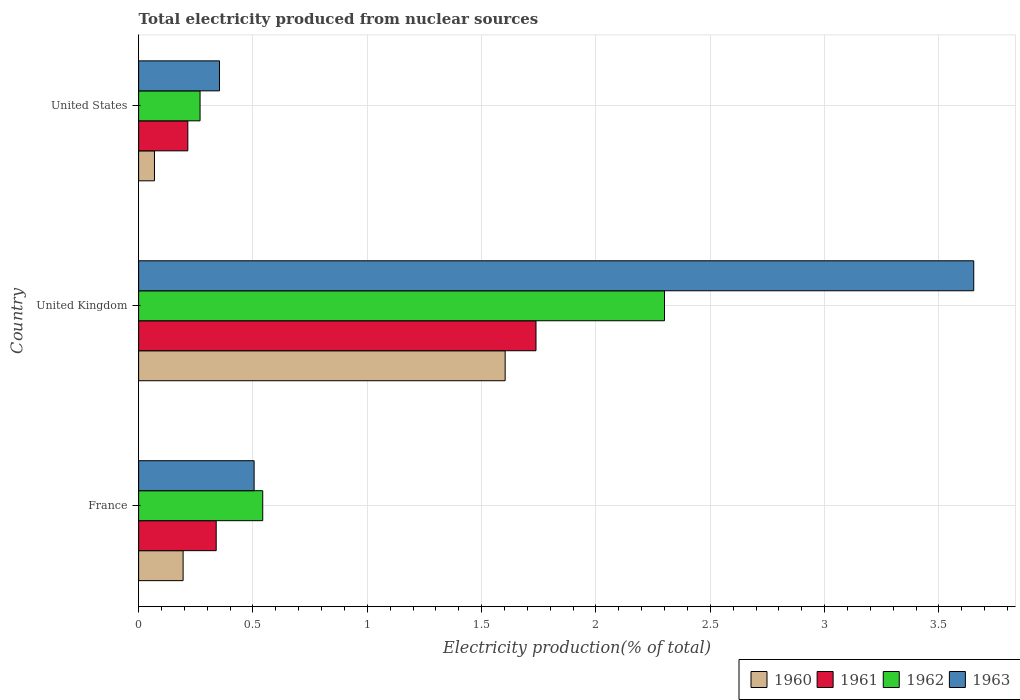How many groups of bars are there?
Offer a terse response. 3. How many bars are there on the 3rd tick from the top?
Make the answer very short. 4. How many bars are there on the 2nd tick from the bottom?
Give a very brief answer. 4. What is the label of the 1st group of bars from the top?
Ensure brevity in your answer.  United States. What is the total electricity produced in 1961 in United Kingdom?
Ensure brevity in your answer.  1.74. Across all countries, what is the maximum total electricity produced in 1961?
Your answer should be very brief. 1.74. Across all countries, what is the minimum total electricity produced in 1963?
Your answer should be very brief. 0.35. In which country was the total electricity produced in 1963 maximum?
Provide a short and direct response. United Kingdom. In which country was the total electricity produced in 1963 minimum?
Keep it short and to the point. United States. What is the total total electricity produced in 1960 in the graph?
Offer a very short reply. 1.87. What is the difference between the total electricity produced in 1961 in France and that in United Kingdom?
Ensure brevity in your answer.  -1.4. What is the difference between the total electricity produced in 1963 in United States and the total electricity produced in 1960 in France?
Ensure brevity in your answer.  0.16. What is the average total electricity produced in 1963 per country?
Your response must be concise. 1.5. What is the difference between the total electricity produced in 1962 and total electricity produced in 1960 in United States?
Ensure brevity in your answer.  0.2. What is the ratio of the total electricity produced in 1961 in France to that in United States?
Offer a very short reply. 1.58. Is the difference between the total electricity produced in 1962 in France and United Kingdom greater than the difference between the total electricity produced in 1960 in France and United Kingdom?
Offer a terse response. No. What is the difference between the highest and the second highest total electricity produced in 1961?
Offer a terse response. 1.4. What is the difference between the highest and the lowest total electricity produced in 1962?
Offer a very short reply. 2.03. What does the 1st bar from the top in United States represents?
Give a very brief answer. 1963. Are all the bars in the graph horizontal?
Your answer should be very brief. Yes. What is the difference between two consecutive major ticks on the X-axis?
Offer a very short reply. 0.5. Are the values on the major ticks of X-axis written in scientific E-notation?
Provide a short and direct response. No. Does the graph contain grids?
Provide a succinct answer. Yes. Where does the legend appear in the graph?
Offer a very short reply. Bottom right. How many legend labels are there?
Offer a very short reply. 4. What is the title of the graph?
Give a very brief answer. Total electricity produced from nuclear sources. Does "1989" appear as one of the legend labels in the graph?
Provide a succinct answer. No. What is the Electricity production(% of total) in 1960 in France?
Give a very brief answer. 0.19. What is the Electricity production(% of total) in 1961 in France?
Offer a terse response. 0.34. What is the Electricity production(% of total) in 1962 in France?
Ensure brevity in your answer.  0.54. What is the Electricity production(% of total) in 1963 in France?
Provide a short and direct response. 0.51. What is the Electricity production(% of total) of 1960 in United Kingdom?
Your answer should be compact. 1.6. What is the Electricity production(% of total) in 1961 in United Kingdom?
Your answer should be very brief. 1.74. What is the Electricity production(% of total) in 1962 in United Kingdom?
Offer a very short reply. 2.3. What is the Electricity production(% of total) in 1963 in United Kingdom?
Your answer should be very brief. 3.65. What is the Electricity production(% of total) of 1960 in United States?
Your response must be concise. 0.07. What is the Electricity production(% of total) of 1961 in United States?
Offer a very short reply. 0.22. What is the Electricity production(% of total) in 1962 in United States?
Offer a very short reply. 0.27. What is the Electricity production(% of total) of 1963 in United States?
Make the answer very short. 0.35. Across all countries, what is the maximum Electricity production(% of total) in 1960?
Make the answer very short. 1.6. Across all countries, what is the maximum Electricity production(% of total) in 1961?
Make the answer very short. 1.74. Across all countries, what is the maximum Electricity production(% of total) in 1962?
Give a very brief answer. 2.3. Across all countries, what is the maximum Electricity production(% of total) in 1963?
Provide a short and direct response. 3.65. Across all countries, what is the minimum Electricity production(% of total) of 1960?
Offer a terse response. 0.07. Across all countries, what is the minimum Electricity production(% of total) of 1961?
Keep it short and to the point. 0.22. Across all countries, what is the minimum Electricity production(% of total) of 1962?
Ensure brevity in your answer.  0.27. Across all countries, what is the minimum Electricity production(% of total) of 1963?
Make the answer very short. 0.35. What is the total Electricity production(% of total) in 1960 in the graph?
Make the answer very short. 1.87. What is the total Electricity production(% of total) in 1961 in the graph?
Your response must be concise. 2.29. What is the total Electricity production(% of total) in 1962 in the graph?
Give a very brief answer. 3.11. What is the total Electricity production(% of total) of 1963 in the graph?
Ensure brevity in your answer.  4.51. What is the difference between the Electricity production(% of total) in 1960 in France and that in United Kingdom?
Your answer should be very brief. -1.41. What is the difference between the Electricity production(% of total) of 1961 in France and that in United Kingdom?
Keep it short and to the point. -1.4. What is the difference between the Electricity production(% of total) in 1962 in France and that in United Kingdom?
Keep it short and to the point. -1.76. What is the difference between the Electricity production(% of total) of 1963 in France and that in United Kingdom?
Keep it short and to the point. -3.15. What is the difference between the Electricity production(% of total) of 1960 in France and that in United States?
Offer a very short reply. 0.13. What is the difference between the Electricity production(% of total) in 1961 in France and that in United States?
Ensure brevity in your answer.  0.12. What is the difference between the Electricity production(% of total) of 1962 in France and that in United States?
Your response must be concise. 0.27. What is the difference between the Electricity production(% of total) in 1963 in France and that in United States?
Make the answer very short. 0.15. What is the difference between the Electricity production(% of total) in 1960 in United Kingdom and that in United States?
Offer a terse response. 1.53. What is the difference between the Electricity production(% of total) in 1961 in United Kingdom and that in United States?
Your answer should be very brief. 1.52. What is the difference between the Electricity production(% of total) in 1962 in United Kingdom and that in United States?
Your answer should be very brief. 2.03. What is the difference between the Electricity production(% of total) of 1963 in United Kingdom and that in United States?
Provide a short and direct response. 3.3. What is the difference between the Electricity production(% of total) of 1960 in France and the Electricity production(% of total) of 1961 in United Kingdom?
Ensure brevity in your answer.  -1.54. What is the difference between the Electricity production(% of total) in 1960 in France and the Electricity production(% of total) in 1962 in United Kingdom?
Offer a terse response. -2.11. What is the difference between the Electricity production(% of total) in 1960 in France and the Electricity production(% of total) in 1963 in United Kingdom?
Your answer should be compact. -3.46. What is the difference between the Electricity production(% of total) of 1961 in France and the Electricity production(% of total) of 1962 in United Kingdom?
Your response must be concise. -1.96. What is the difference between the Electricity production(% of total) in 1961 in France and the Electricity production(% of total) in 1963 in United Kingdom?
Give a very brief answer. -3.31. What is the difference between the Electricity production(% of total) of 1962 in France and the Electricity production(% of total) of 1963 in United Kingdom?
Your answer should be very brief. -3.11. What is the difference between the Electricity production(% of total) of 1960 in France and the Electricity production(% of total) of 1961 in United States?
Ensure brevity in your answer.  -0.02. What is the difference between the Electricity production(% of total) of 1960 in France and the Electricity production(% of total) of 1962 in United States?
Provide a short and direct response. -0.07. What is the difference between the Electricity production(% of total) in 1960 in France and the Electricity production(% of total) in 1963 in United States?
Offer a terse response. -0.16. What is the difference between the Electricity production(% of total) in 1961 in France and the Electricity production(% of total) in 1962 in United States?
Give a very brief answer. 0.07. What is the difference between the Electricity production(% of total) in 1961 in France and the Electricity production(% of total) in 1963 in United States?
Your answer should be compact. -0.01. What is the difference between the Electricity production(% of total) in 1962 in France and the Electricity production(% of total) in 1963 in United States?
Your answer should be compact. 0.19. What is the difference between the Electricity production(% of total) of 1960 in United Kingdom and the Electricity production(% of total) of 1961 in United States?
Make the answer very short. 1.39. What is the difference between the Electricity production(% of total) in 1960 in United Kingdom and the Electricity production(% of total) in 1962 in United States?
Give a very brief answer. 1.33. What is the difference between the Electricity production(% of total) in 1960 in United Kingdom and the Electricity production(% of total) in 1963 in United States?
Provide a succinct answer. 1.25. What is the difference between the Electricity production(% of total) in 1961 in United Kingdom and the Electricity production(% of total) in 1962 in United States?
Your response must be concise. 1.47. What is the difference between the Electricity production(% of total) of 1961 in United Kingdom and the Electricity production(% of total) of 1963 in United States?
Ensure brevity in your answer.  1.38. What is the difference between the Electricity production(% of total) of 1962 in United Kingdom and the Electricity production(% of total) of 1963 in United States?
Give a very brief answer. 1.95. What is the average Electricity production(% of total) of 1960 per country?
Offer a terse response. 0.62. What is the average Electricity production(% of total) of 1961 per country?
Offer a very short reply. 0.76. What is the average Electricity production(% of total) of 1963 per country?
Offer a very short reply. 1.5. What is the difference between the Electricity production(% of total) in 1960 and Electricity production(% of total) in 1961 in France?
Your answer should be compact. -0.14. What is the difference between the Electricity production(% of total) in 1960 and Electricity production(% of total) in 1962 in France?
Give a very brief answer. -0.35. What is the difference between the Electricity production(% of total) in 1960 and Electricity production(% of total) in 1963 in France?
Your response must be concise. -0.31. What is the difference between the Electricity production(% of total) in 1961 and Electricity production(% of total) in 1962 in France?
Your response must be concise. -0.2. What is the difference between the Electricity production(% of total) in 1961 and Electricity production(% of total) in 1963 in France?
Make the answer very short. -0.17. What is the difference between the Electricity production(% of total) of 1962 and Electricity production(% of total) of 1963 in France?
Provide a succinct answer. 0.04. What is the difference between the Electricity production(% of total) of 1960 and Electricity production(% of total) of 1961 in United Kingdom?
Make the answer very short. -0.13. What is the difference between the Electricity production(% of total) in 1960 and Electricity production(% of total) in 1962 in United Kingdom?
Keep it short and to the point. -0.7. What is the difference between the Electricity production(% of total) of 1960 and Electricity production(% of total) of 1963 in United Kingdom?
Offer a very short reply. -2.05. What is the difference between the Electricity production(% of total) in 1961 and Electricity production(% of total) in 1962 in United Kingdom?
Give a very brief answer. -0.56. What is the difference between the Electricity production(% of total) in 1961 and Electricity production(% of total) in 1963 in United Kingdom?
Give a very brief answer. -1.91. What is the difference between the Electricity production(% of total) of 1962 and Electricity production(% of total) of 1963 in United Kingdom?
Your response must be concise. -1.35. What is the difference between the Electricity production(% of total) in 1960 and Electricity production(% of total) in 1961 in United States?
Offer a terse response. -0.15. What is the difference between the Electricity production(% of total) in 1960 and Electricity production(% of total) in 1962 in United States?
Provide a succinct answer. -0.2. What is the difference between the Electricity production(% of total) of 1960 and Electricity production(% of total) of 1963 in United States?
Provide a short and direct response. -0.28. What is the difference between the Electricity production(% of total) of 1961 and Electricity production(% of total) of 1962 in United States?
Offer a very short reply. -0.05. What is the difference between the Electricity production(% of total) in 1961 and Electricity production(% of total) in 1963 in United States?
Ensure brevity in your answer.  -0.14. What is the difference between the Electricity production(% of total) of 1962 and Electricity production(% of total) of 1963 in United States?
Keep it short and to the point. -0.09. What is the ratio of the Electricity production(% of total) in 1960 in France to that in United Kingdom?
Provide a succinct answer. 0.12. What is the ratio of the Electricity production(% of total) in 1961 in France to that in United Kingdom?
Provide a short and direct response. 0.2. What is the ratio of the Electricity production(% of total) in 1962 in France to that in United Kingdom?
Offer a very short reply. 0.24. What is the ratio of the Electricity production(% of total) of 1963 in France to that in United Kingdom?
Provide a succinct answer. 0.14. What is the ratio of the Electricity production(% of total) of 1960 in France to that in United States?
Your response must be concise. 2.81. What is the ratio of the Electricity production(% of total) in 1961 in France to that in United States?
Your answer should be very brief. 1.58. What is the ratio of the Electricity production(% of total) in 1962 in France to that in United States?
Offer a very short reply. 2.02. What is the ratio of the Electricity production(% of total) in 1963 in France to that in United States?
Your answer should be compact. 1.43. What is the ratio of the Electricity production(% of total) in 1960 in United Kingdom to that in United States?
Offer a very short reply. 23.14. What is the ratio of the Electricity production(% of total) of 1961 in United Kingdom to that in United States?
Make the answer very short. 8.08. What is the ratio of the Electricity production(% of total) in 1962 in United Kingdom to that in United States?
Offer a very short reply. 8.56. What is the ratio of the Electricity production(% of total) in 1963 in United Kingdom to that in United States?
Ensure brevity in your answer.  10.32. What is the difference between the highest and the second highest Electricity production(% of total) of 1960?
Your answer should be very brief. 1.41. What is the difference between the highest and the second highest Electricity production(% of total) in 1961?
Your answer should be compact. 1.4. What is the difference between the highest and the second highest Electricity production(% of total) in 1962?
Offer a very short reply. 1.76. What is the difference between the highest and the second highest Electricity production(% of total) in 1963?
Offer a very short reply. 3.15. What is the difference between the highest and the lowest Electricity production(% of total) in 1960?
Give a very brief answer. 1.53. What is the difference between the highest and the lowest Electricity production(% of total) of 1961?
Your answer should be very brief. 1.52. What is the difference between the highest and the lowest Electricity production(% of total) in 1962?
Give a very brief answer. 2.03. What is the difference between the highest and the lowest Electricity production(% of total) of 1963?
Provide a short and direct response. 3.3. 